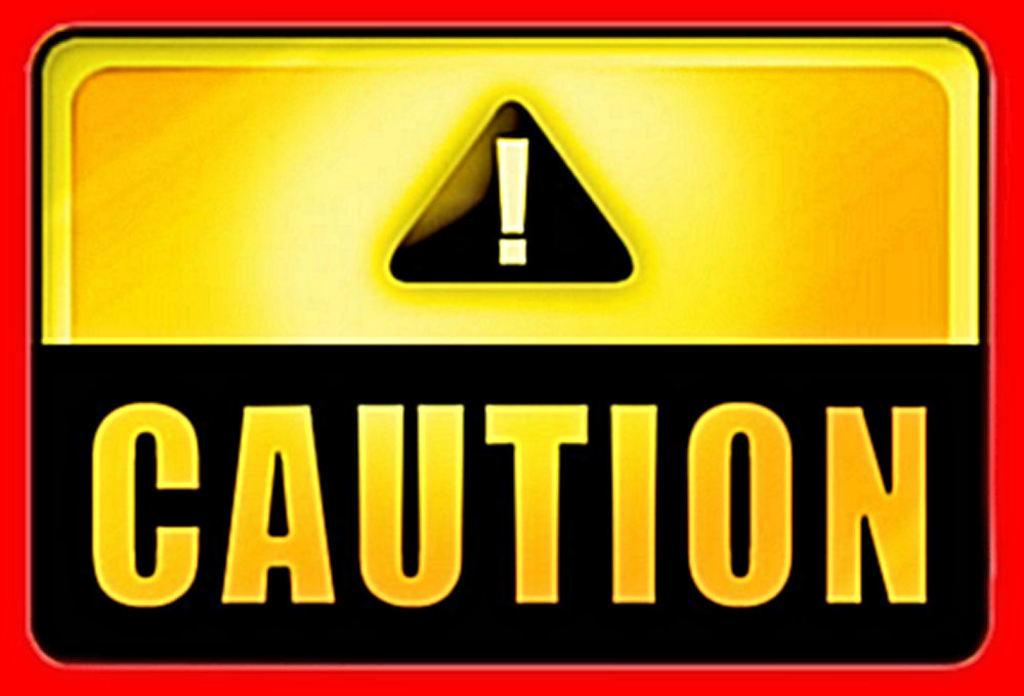What is the main subject of the image? The main subject of the image is an edited image in the center. What can be found within the edited image? The edited image contains text and a logo. What is the title of the mass in the image? There is no mass or title present in the image; it features an edited image with text and a logo. 